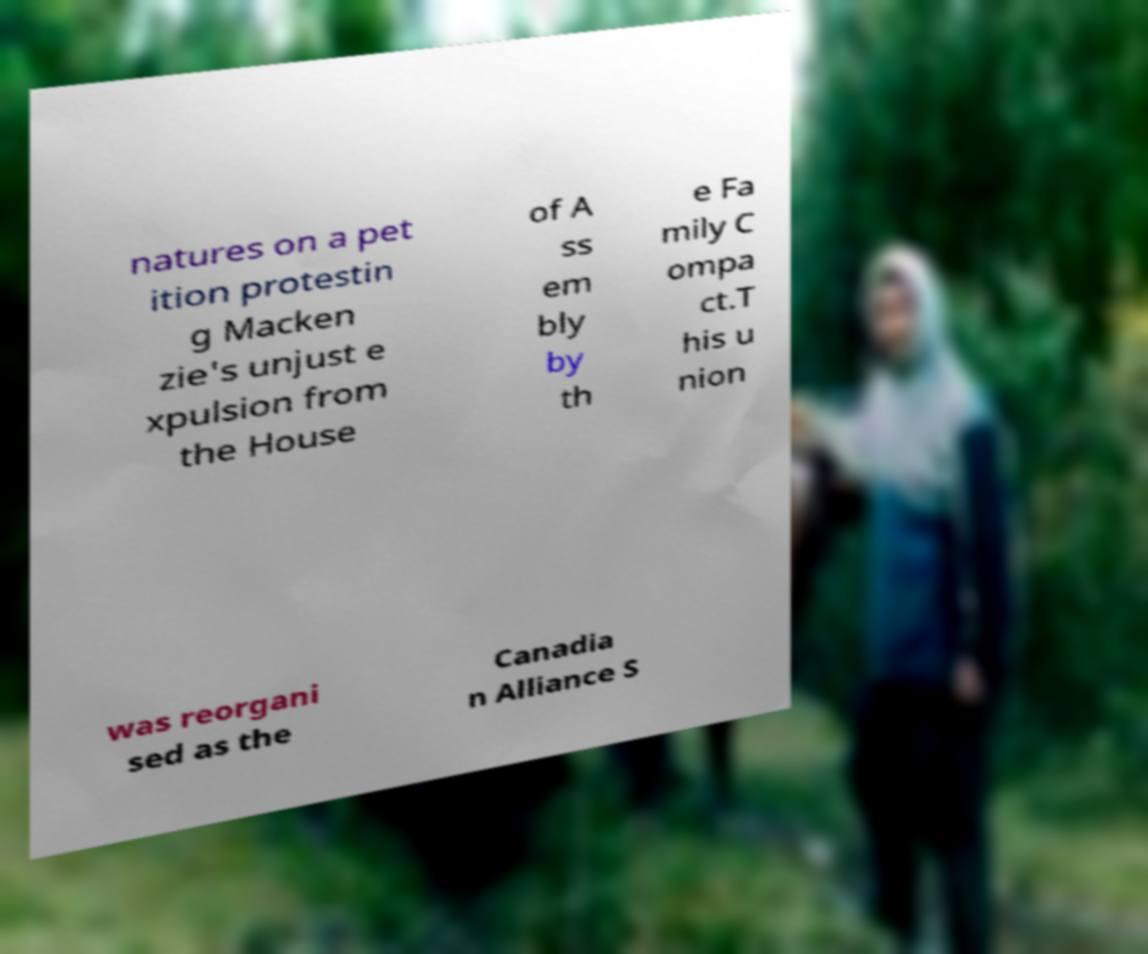For documentation purposes, I need the text within this image transcribed. Could you provide that? natures on a pet ition protestin g Macken zie's unjust e xpulsion from the House of A ss em bly by th e Fa mily C ompa ct.T his u nion was reorgani sed as the Canadia n Alliance S 